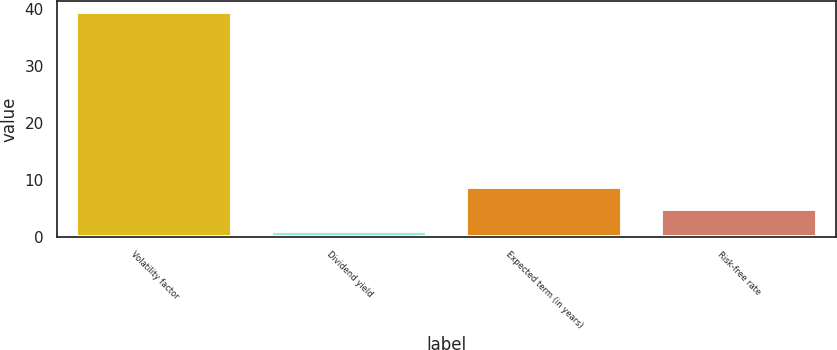Convert chart to OTSL. <chart><loc_0><loc_0><loc_500><loc_500><bar_chart><fcel>Volatility factor<fcel>Dividend yield<fcel>Expected term (in years)<fcel>Risk-free rate<nl><fcel>39.4<fcel>1<fcel>8.68<fcel>4.84<nl></chart> 